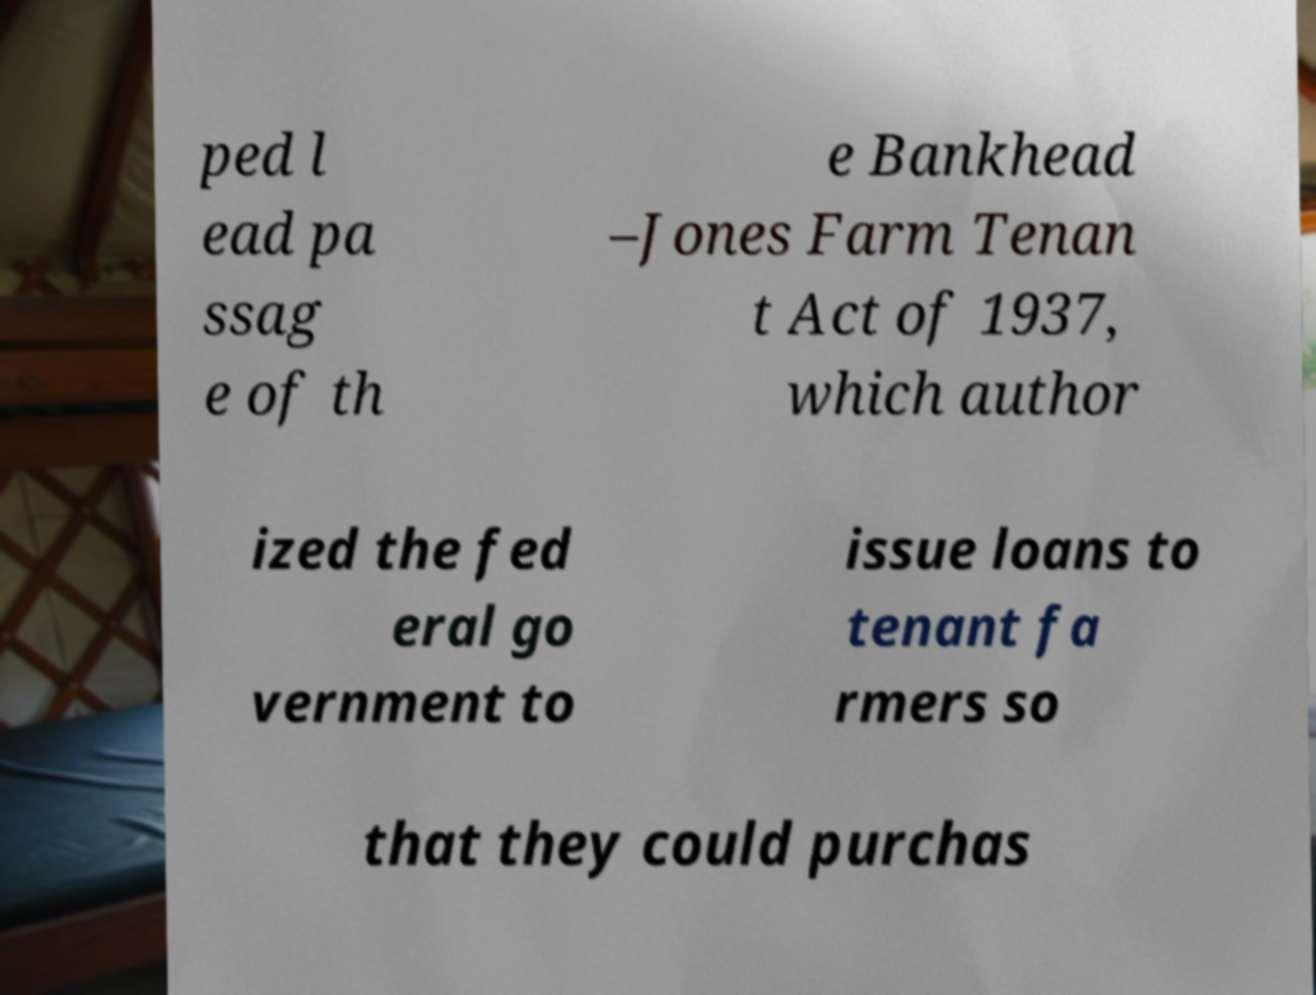Can you accurately transcribe the text from the provided image for me? ped l ead pa ssag e of th e Bankhead –Jones Farm Tenan t Act of 1937, which author ized the fed eral go vernment to issue loans to tenant fa rmers so that they could purchas 